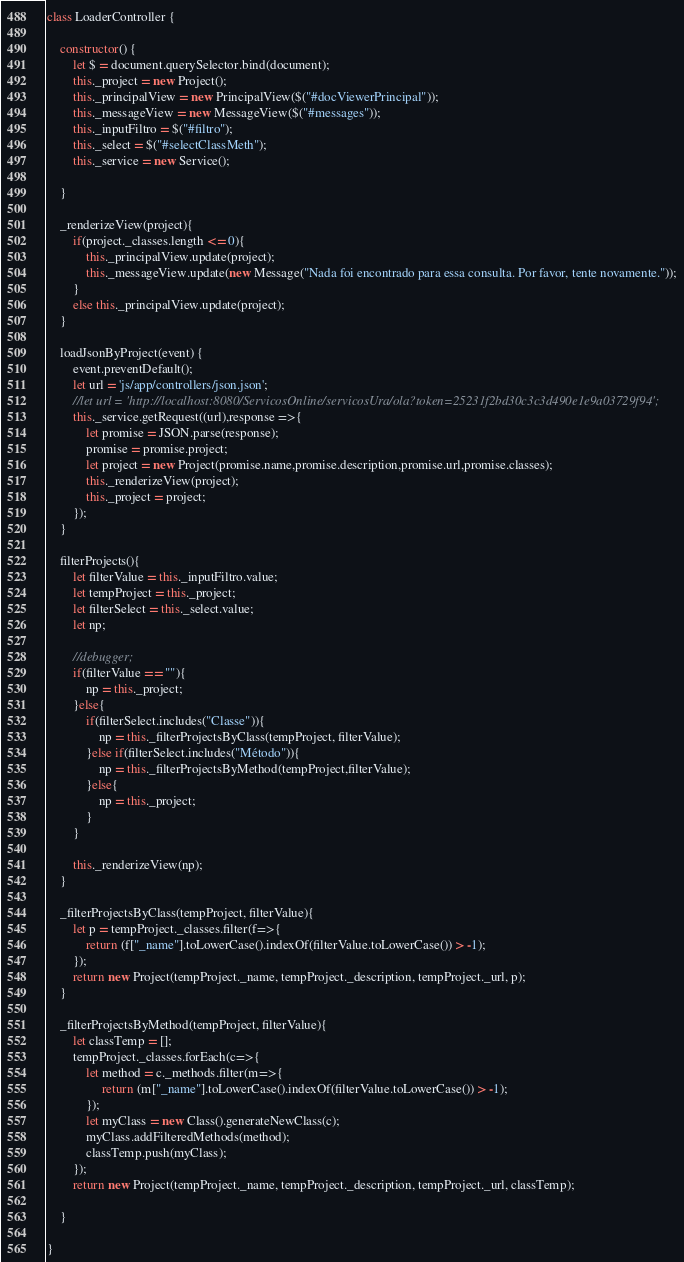<code> <loc_0><loc_0><loc_500><loc_500><_JavaScript_>
class LoaderController {

    constructor() {
        let $ = document.querySelector.bind(document);
        this._project = new Project();
        this._principalView = new PrincipalView($("#docViewerPrincipal"));
        this._messageView = new MessageView($("#messages"));
        this._inputFiltro = $("#filtro");
        this._select = $("#selectClassMeth");
        this._service = new Service();

    }

    _renderizeView(project){
        if(project._classes.length <= 0){
            this._principalView.update(project);
            this._messageView.update(new Message("Nada foi encontrado para essa consulta. Por favor, tente novamente."));
        }
        else this._principalView.update(project);
    }
    
    loadJsonByProject(event) {
        event.preventDefault();
        let url = 'js/app/controllers/json.json';
        //let url = 'http://localhost:8080/ServicosOnline/servicosUra/ola?token=25231f2bd30c3c3d490e1e9a03729f94';
        this._service.getRequest((url),response =>{
            let promise = JSON.parse(response);
            promise = promise.project;
            let project = new Project(promise.name,promise.description,promise.url,promise.classes);
            this._renderizeView(project);
            this._project = project;
        });
    }

    filterProjects(){
        let filterValue = this._inputFiltro.value;
        let tempProject = this._project;
        let filterSelect = this._select.value;
        let np;

        //debugger;
        if(filterValue == ""){
            np = this._project;
        }else{
            if(filterSelect.includes("Classe")){
                np = this._filterProjectsByClass(tempProject, filterValue);
            }else if(filterSelect.includes("Método")){
                np = this._filterProjectsByMethod(tempProject,filterValue);
            }else{
                np = this._project;
            }
        }
       
        this._renderizeView(np);
    }

    _filterProjectsByClass(tempProject, filterValue){
        let p = tempProject._classes.filter(f=>{
            return (f["_name"].toLowerCase().indexOf(filterValue.toLowerCase()) > -1);
        });
        return new Project(tempProject._name, tempProject._description, tempProject._url, p);
    }

    _filterProjectsByMethod(tempProject, filterValue){
        let classTemp = [];
        tempProject._classes.forEach(c=>{
            let method = c._methods.filter(m=>{
                 return (m["_name"].toLowerCase().indexOf(filterValue.toLowerCase()) > -1);
            });
            let myClass = new Class().generateNewClass(c);
            myClass.addFilteredMethods(method);
            classTemp.push(myClass);
        });
        return new Project(tempProject._name, tempProject._description, tempProject._url, classTemp);

    }

}</code> 